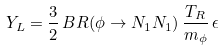Convert formula to latex. <formula><loc_0><loc_0><loc_500><loc_500>Y _ { L } = \frac { 3 } { 2 } \, B R ( \phi \rightarrow N _ { 1 } N _ { 1 } ) \, \frac { T _ { R } } { m _ { \phi } } \, \epsilon</formula> 